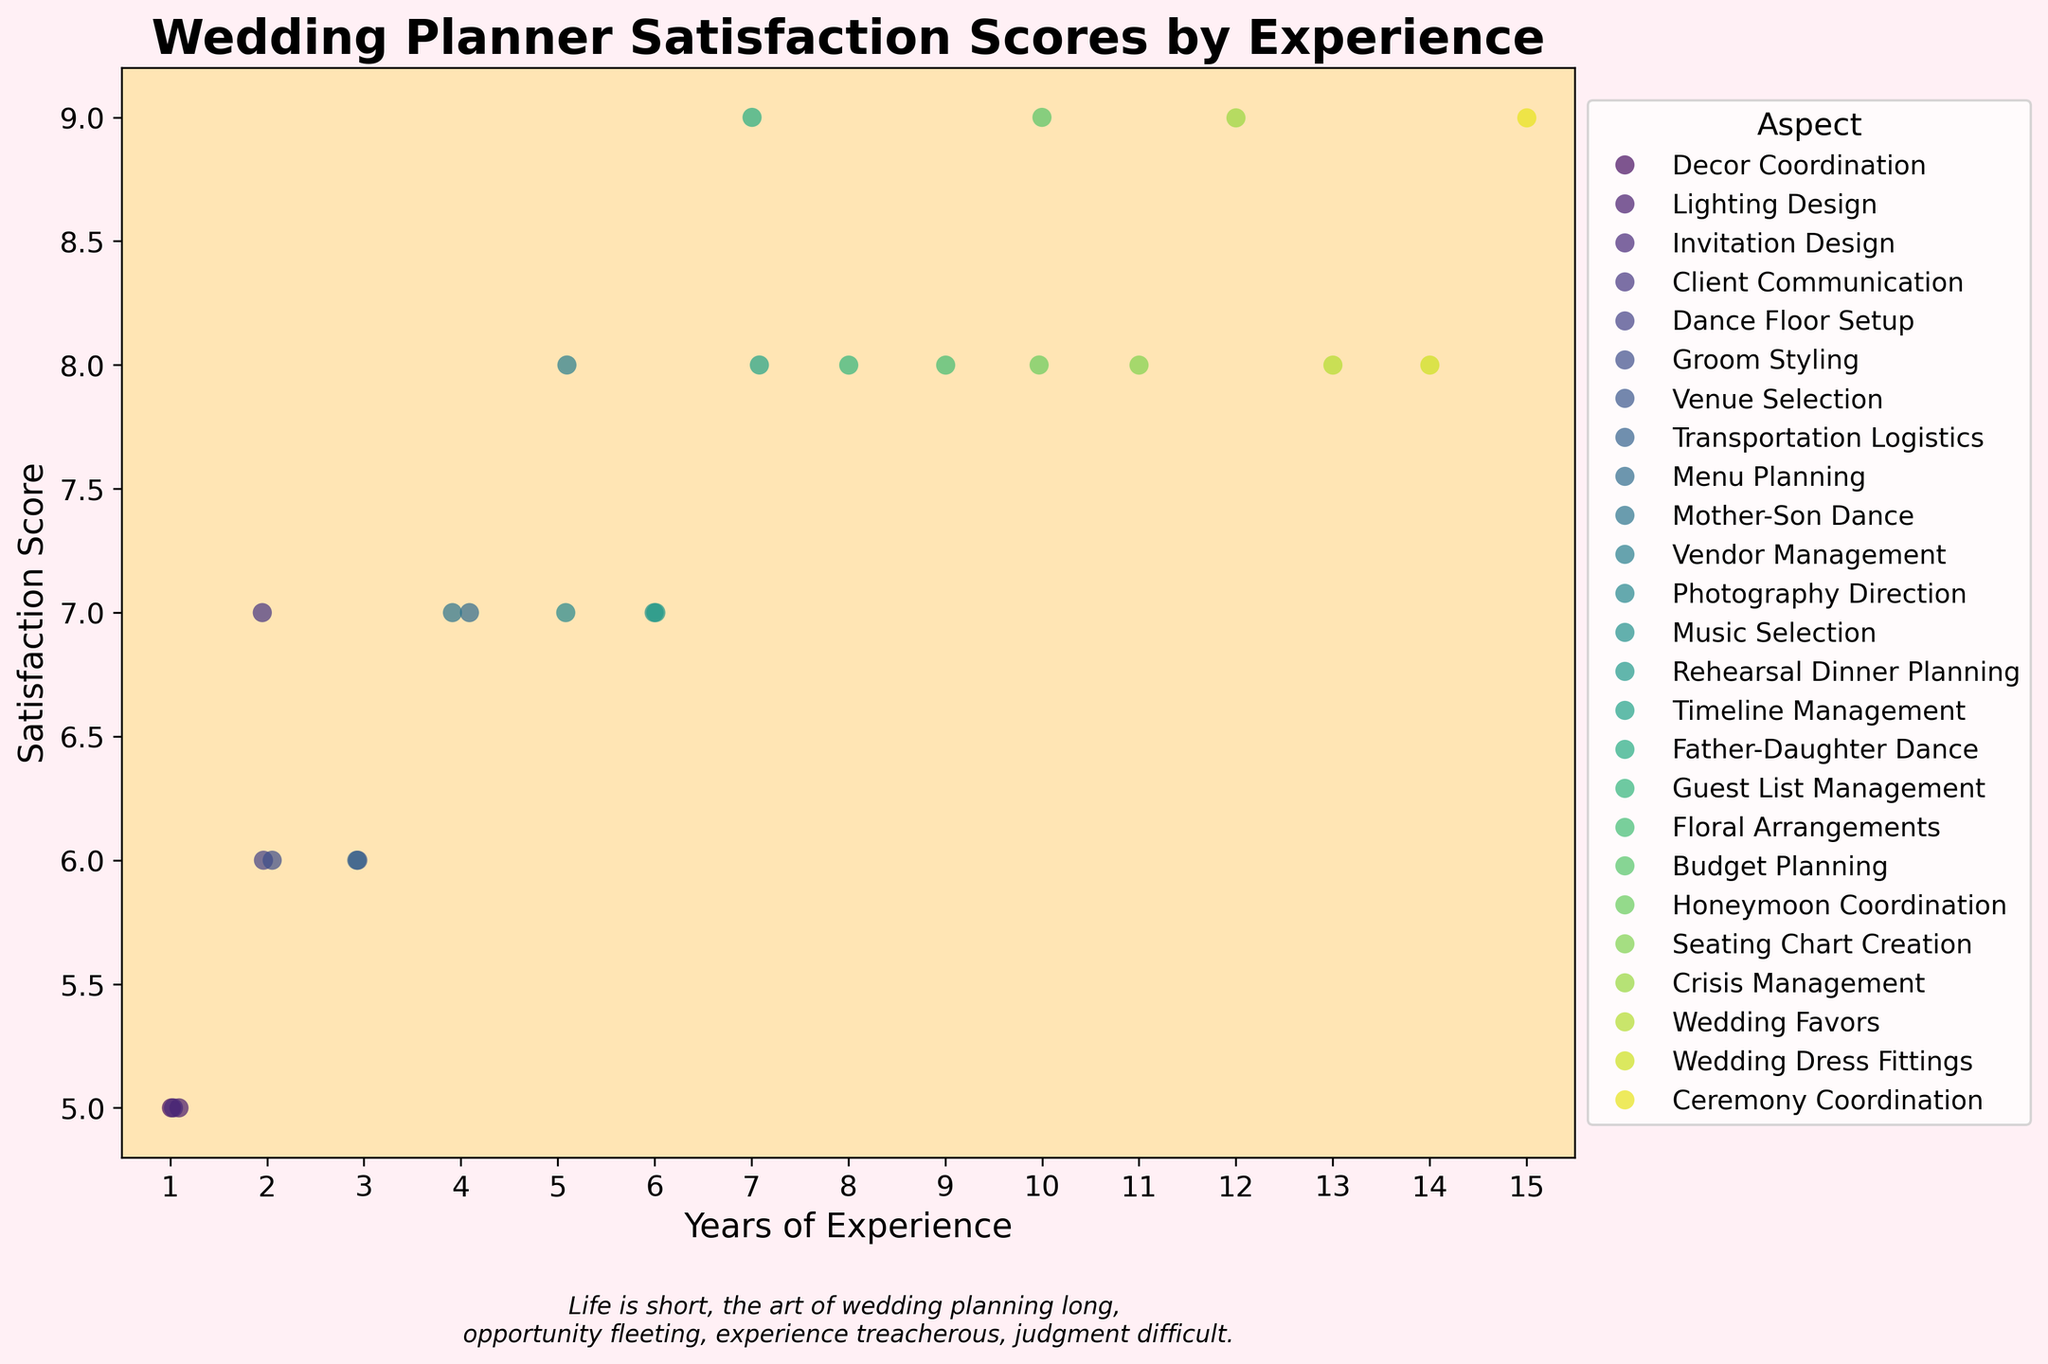What is the title of the figure? It's displayed at the top of the plot. The text reads "Wedding Planner Satisfaction Scores by Experience".
Answer: Wedding Planner Satisfaction Scores by Experience What is the highest satisfaction score recorded and for which aspect? Looking at the highest point on the y-axis, we see a score of 9. Checking the legend, these scores pertain to aspects like Budget Planning, Crisis Management, Ceremony Coordination, and Father-Daughter Dance.
Answer: 9 for Budget Planning, Crisis Management, Ceremony Coordination, and Father-Daughter Dance In the range of 5 to 10 years of experience, which aspects have a satisfaction score of 8? Scan horizontally across the strip plot for the years 5 to 10 and check the hue legend. The aspects with a satisfaction score of 8 are Vendor Management (5 years), Timeline Management (7 years), Guest List Management (8 years), and Honeymoon Coordination (10 years).
Answer: Vendor Management, Timeline Management, Guest List Management, and Honeymoon Coordination Which years of experience have the lowest recorded satisfaction score and what are those aspects? The lowest score is 5 on the y-axis. Find the corresponding data points; they are for years of experience 1 and aspects Decor Coordination, Lighting Design, and Invitation Design.
Answer: 1 year for Decor Coordination, Lighting Design, and Invitation Design How many different aspects are visualized in the plot? The legend on the side lists all unique aspects represented. Counting them gives us 19 aspects in total.
Answer: 19 aspects Do wedding planners with more than 10 years of experience generally have higher satisfaction scores for their job? Assess the data points to the right of the 10-year mark. Notice that most of these points are high on the y-axis, with many scoring 8 or 9.
Answer: Yes Compare the satisfaction scores for planners with 1-3 years of experience and those with 12-15 years. Which group generally has higher scores? Observe points for 1-3 years (generally around 5-7) and for 12-15 years (mostly at 8-9). Planners with 12-15 years have higher scores.
Answer: Planners with 12-15 years Is there an aspect that consistently scores high regardless of experience? Budget Planning, Crisis Management, and Ceremony Coordination receive scores of 9 across different experience levels, indicating consistent high satisfaction.
Answer: Budget Planning, Crisis Management, and Ceremony Coordination Which aspects have satisfaction scores of between 6 and 7 across a range of experience levels? Look for scores between 6 and 7 distributed across experience levels. Aspects like Venue Selection, Dance Floor Setup, Groom Styling, Transportation Logistics, Music Selection, and Photography Direction fit this criterion.
Answer: Venue Selection, Dance Floor Setup, Groom Styling, Transportation Logistics, Music Selection, and Photography Direction 